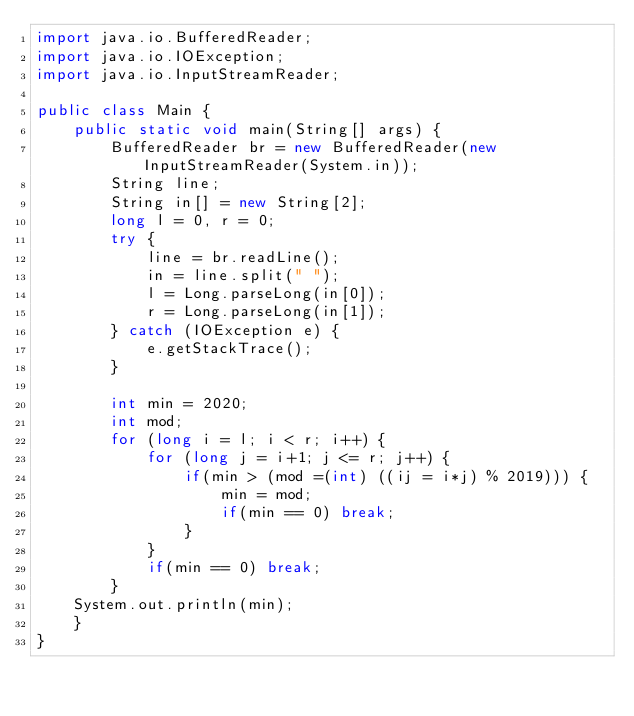Convert code to text. <code><loc_0><loc_0><loc_500><loc_500><_Java_>import java.io.BufferedReader;
import java.io.IOException;
import java.io.InputStreamReader;

public class Main {
	public static void main(String[] args) {
		BufferedReader br = new BufferedReader(new InputStreamReader(System.in));
		String line;
		String in[] = new String[2];
		long l = 0, r = 0;
		try {
			line = br.readLine();
			in = line.split(" ");
			l = Long.parseLong(in[0]);
			r = Long.parseLong(in[1]);
		} catch (IOException e) {
			e.getStackTrace();
		}
		
		int min = 2020;
		int mod;
		for (long i = l; i < r; i++) {
			for (long j = i+1; j <= r; j++) {
				if(min > (mod =(int) ((ij = i*j) % 2019))) {
					min = mod;
					if(min == 0) break;
				}
			}
			if(min == 0) break;
		}
	System.out.println(min);		
	}
}</code> 